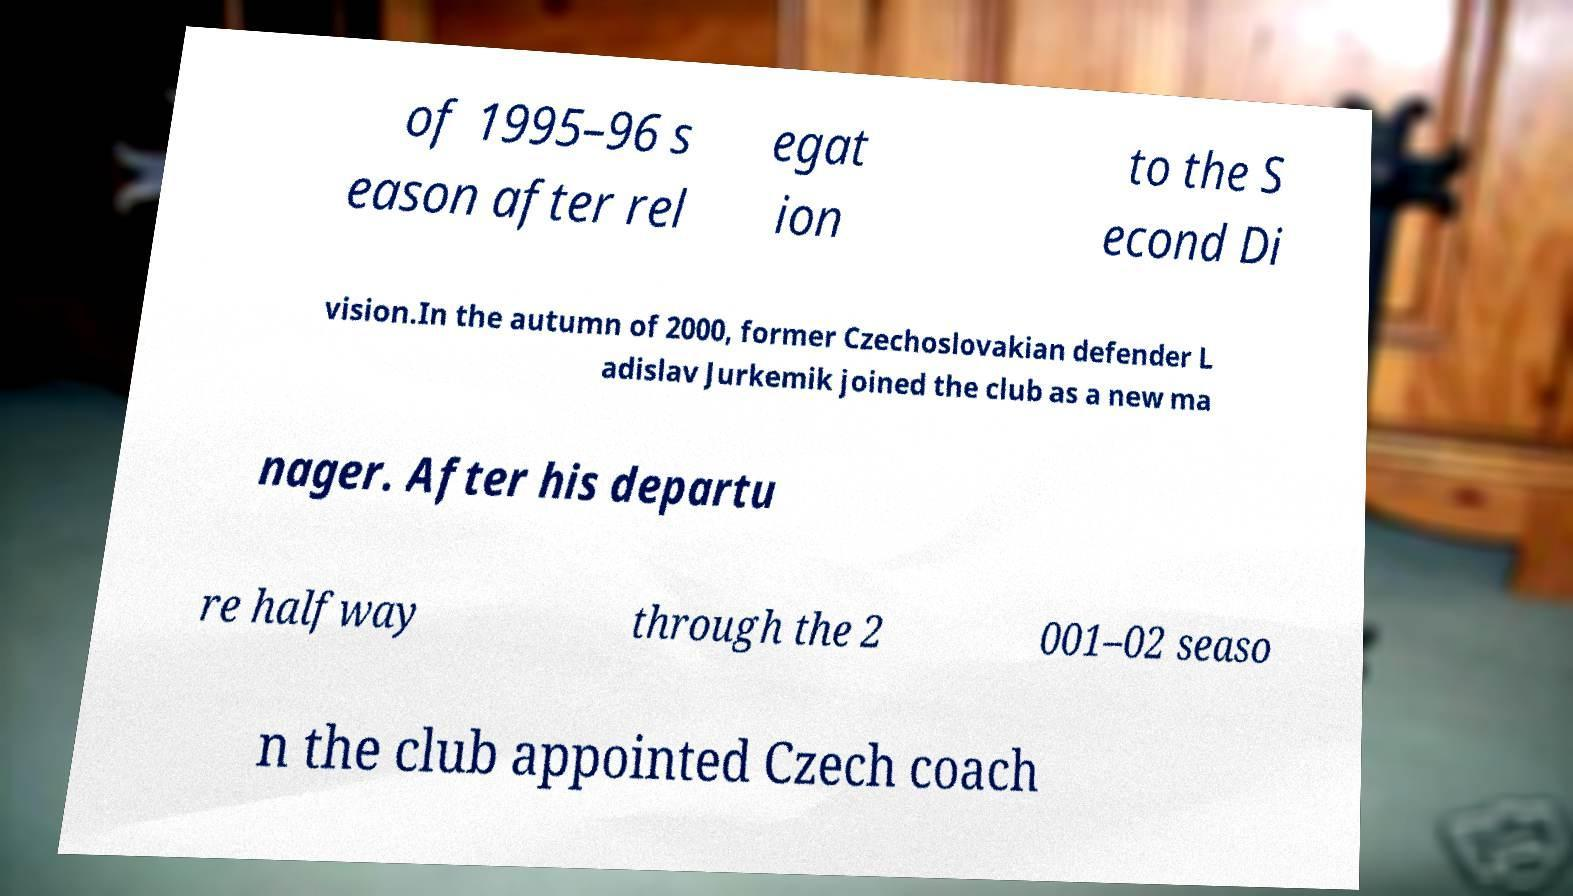I need the written content from this picture converted into text. Can you do that? of 1995–96 s eason after rel egat ion to the S econd Di vision.In the autumn of 2000, former Czechoslovakian defender L adislav Jurkemik joined the club as a new ma nager. After his departu re halfway through the 2 001–02 seaso n the club appointed Czech coach 